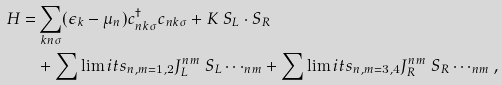Convert formula to latex. <formula><loc_0><loc_0><loc_500><loc_500>H = & \sum _ { { k } n \sigma } ( \epsilon _ { k } - \mu _ { n } ) c ^ { \dagger } _ { n { k } \sigma } c _ { n { k } \sigma } + K \ S _ { L } \cdot S _ { R } \\ & + { \sum \lim i t s _ { n , m = 1 , 2 } } J _ { L } ^ { n m } \ S _ { L } \cdots _ { n m } + { \sum \lim i t s _ { n , m = 3 , 4 } } J _ { R } ^ { n m } \ S _ { R } \cdots _ { n m } ,</formula> 